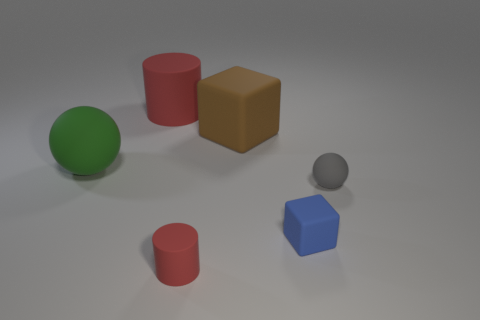There is another rubber thing that is the same shape as the gray object; what size is it?
Make the answer very short. Large. Is there any other thing that is the same size as the blue rubber cube?
Your answer should be very brief. Yes. How many other objects are the same color as the big ball?
Provide a short and direct response. 0. How many balls are big red objects or big matte things?
Your answer should be compact. 1. There is a large block on the right side of the small rubber object that is on the left side of the brown rubber object; what color is it?
Your answer should be very brief. Brown. There is a brown rubber thing; what shape is it?
Provide a succinct answer. Cube. Is the size of the matte block in front of the green ball the same as the big green matte ball?
Offer a terse response. No. Is there a big thing that has the same material as the large cube?
Offer a terse response. Yes. How many objects are either red things right of the large red object or tiny rubber things?
Offer a very short reply. 3. Are there any small blue rubber blocks?
Provide a succinct answer. Yes. 